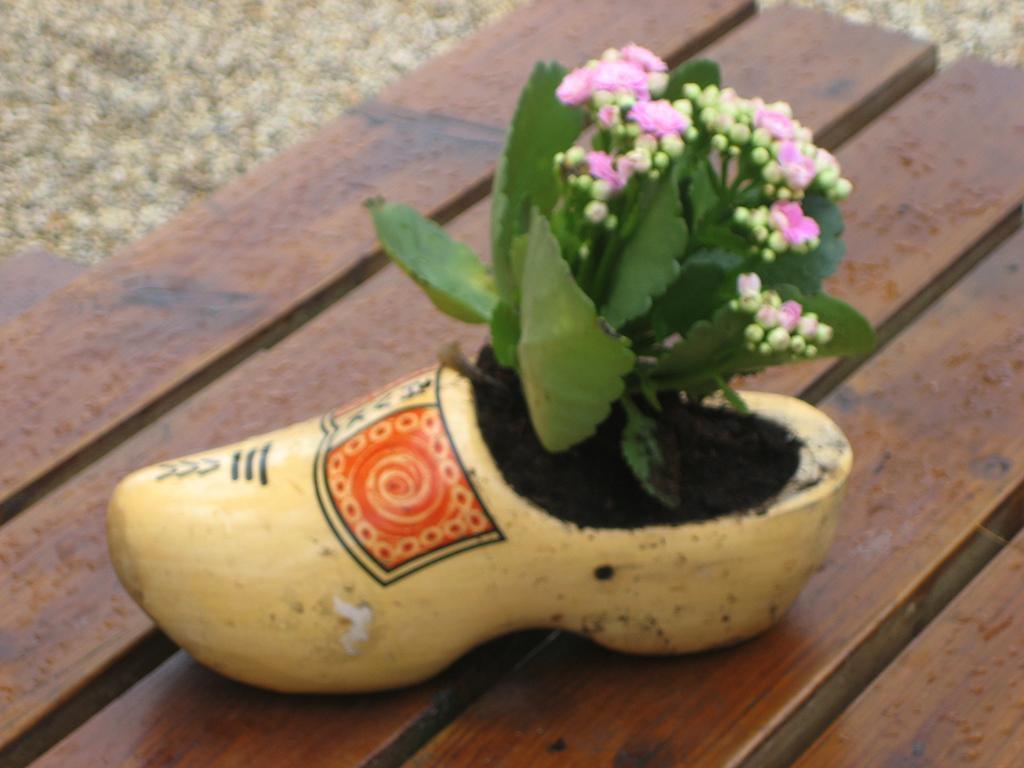In one or two sentences, can you explain what this image depicts? There is a wooden surface. On that there is a pot in the shape of a shoe. In that there is a plant with flowers. 